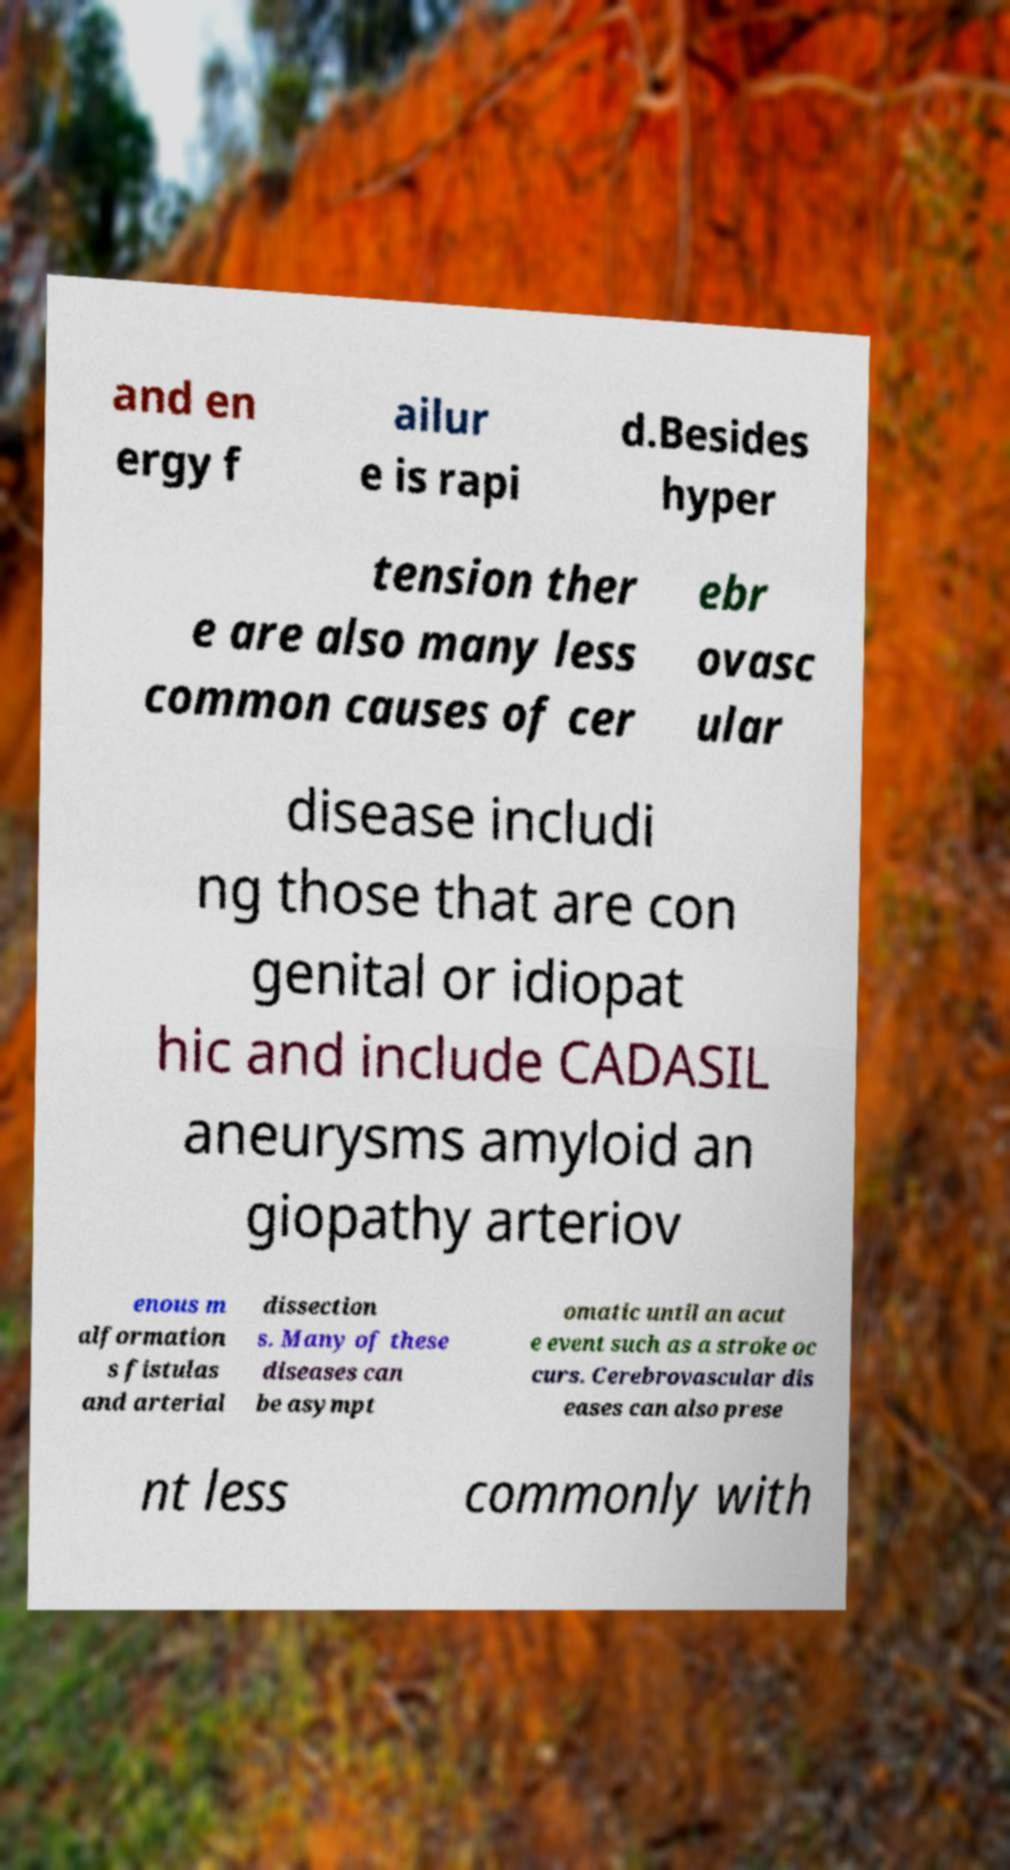Please identify and transcribe the text found in this image. and en ergy f ailur e is rapi d.Besides hyper tension ther e are also many less common causes of cer ebr ovasc ular disease includi ng those that are con genital or idiopat hic and include CADASIL aneurysms amyloid an giopathy arteriov enous m alformation s fistulas and arterial dissection s. Many of these diseases can be asympt omatic until an acut e event such as a stroke oc curs. Cerebrovascular dis eases can also prese nt less commonly with 